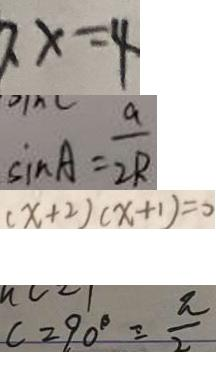<formula> <loc_0><loc_0><loc_500><loc_500>x = 4 
 \sin A = \frac { a } { 2 R } 
 ( x + 2 ) ( x + 1 ) = 0 
 c = 9 0 ^ { \circ } = \frac { \pi } { 2 }</formula> 